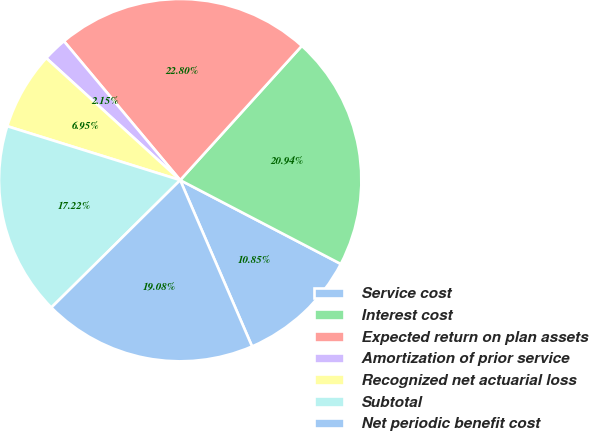Convert chart to OTSL. <chart><loc_0><loc_0><loc_500><loc_500><pie_chart><fcel>Service cost<fcel>Interest cost<fcel>Expected return on plan assets<fcel>Amortization of prior service<fcel>Recognized net actuarial loss<fcel>Subtotal<fcel>Net periodic benefit cost<nl><fcel>10.85%<fcel>20.94%<fcel>22.8%<fcel>2.15%<fcel>6.95%<fcel>17.22%<fcel>19.08%<nl></chart> 